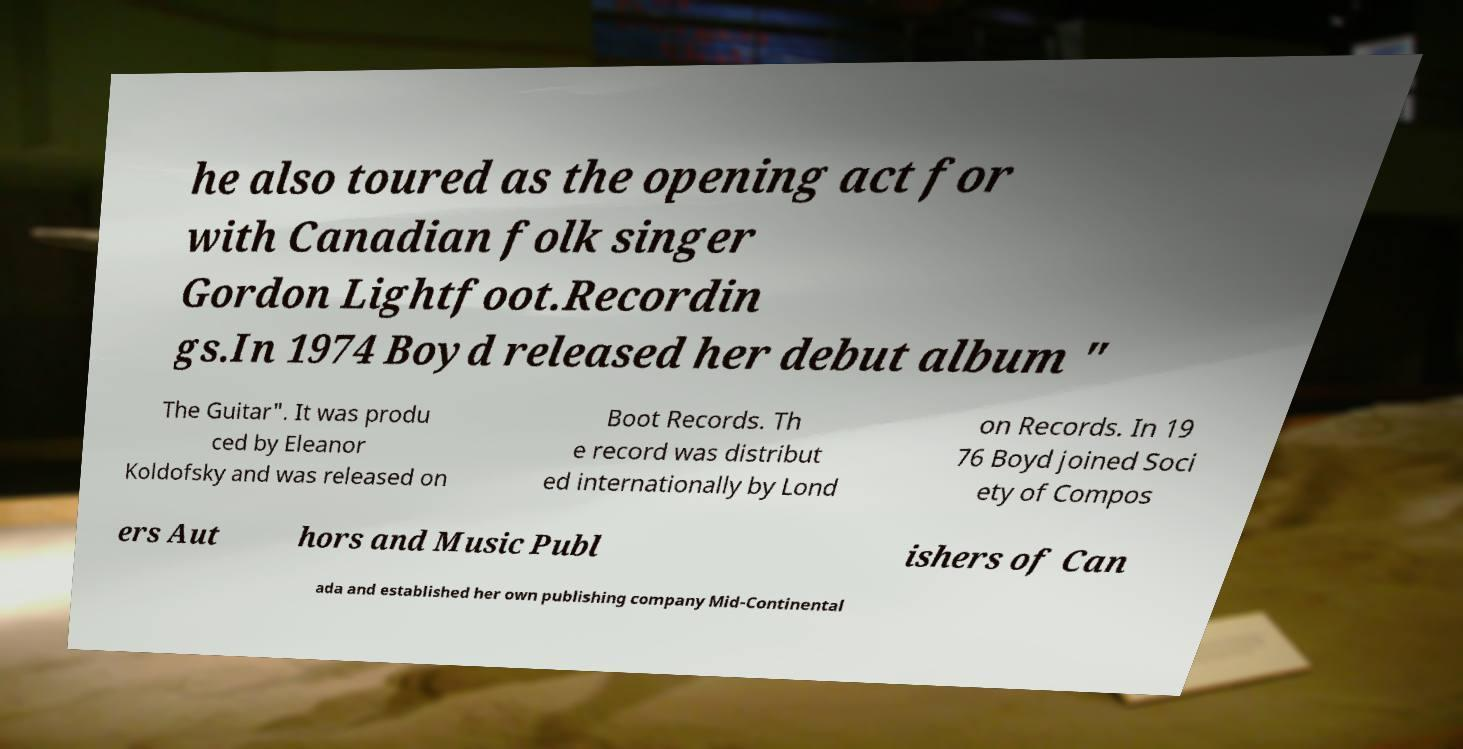Could you assist in decoding the text presented in this image and type it out clearly? he also toured as the opening act for with Canadian folk singer Gordon Lightfoot.Recordin gs.In 1974 Boyd released her debut album " The Guitar". It was produ ced by Eleanor Koldofsky and was released on Boot Records. Th e record was distribut ed internationally by Lond on Records. In 19 76 Boyd joined Soci ety of Compos ers Aut hors and Music Publ ishers of Can ada and established her own publishing company Mid-Continental 